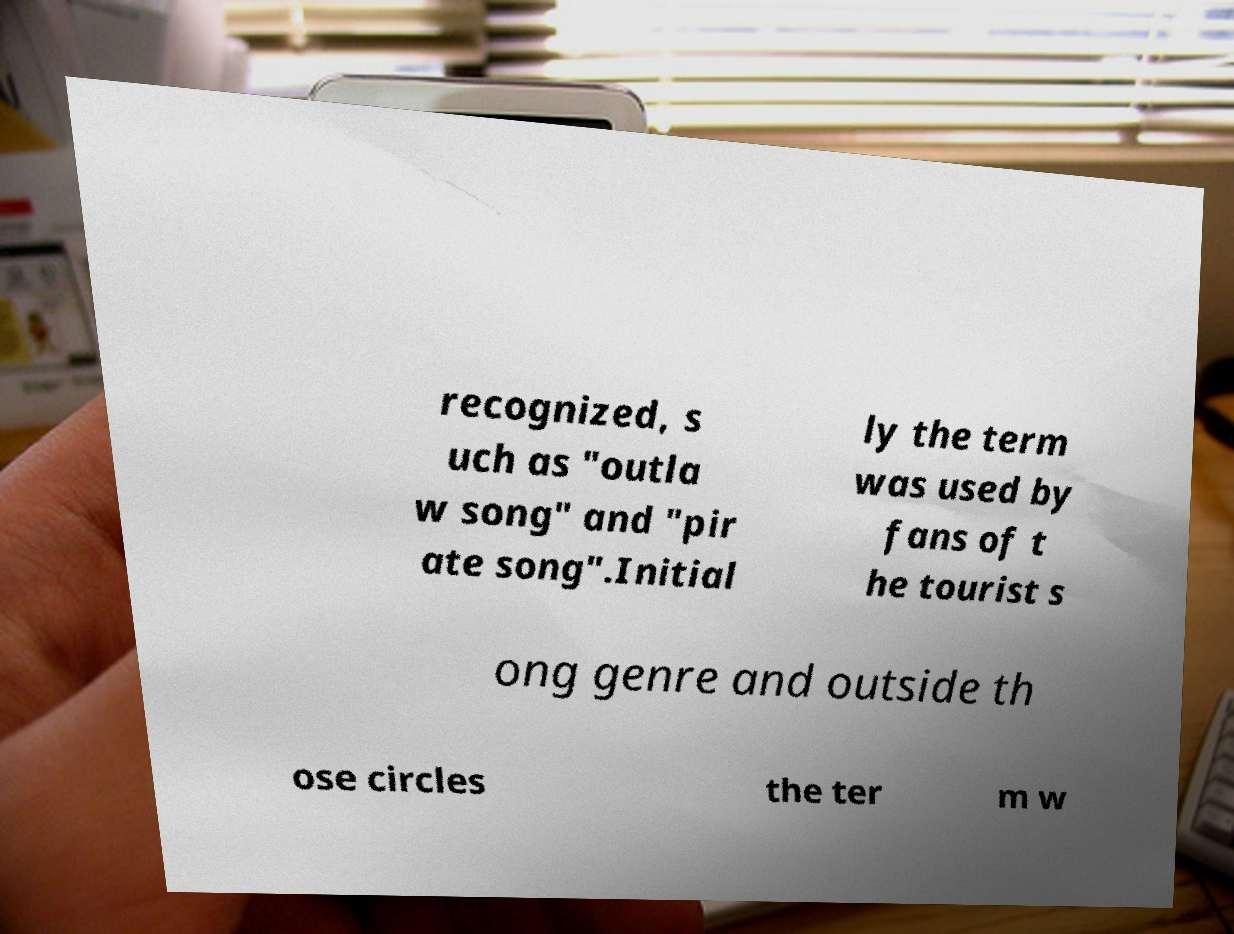Can you accurately transcribe the text from the provided image for me? recognized, s uch as "outla w song" and "pir ate song".Initial ly the term was used by fans of t he tourist s ong genre and outside th ose circles the ter m w 